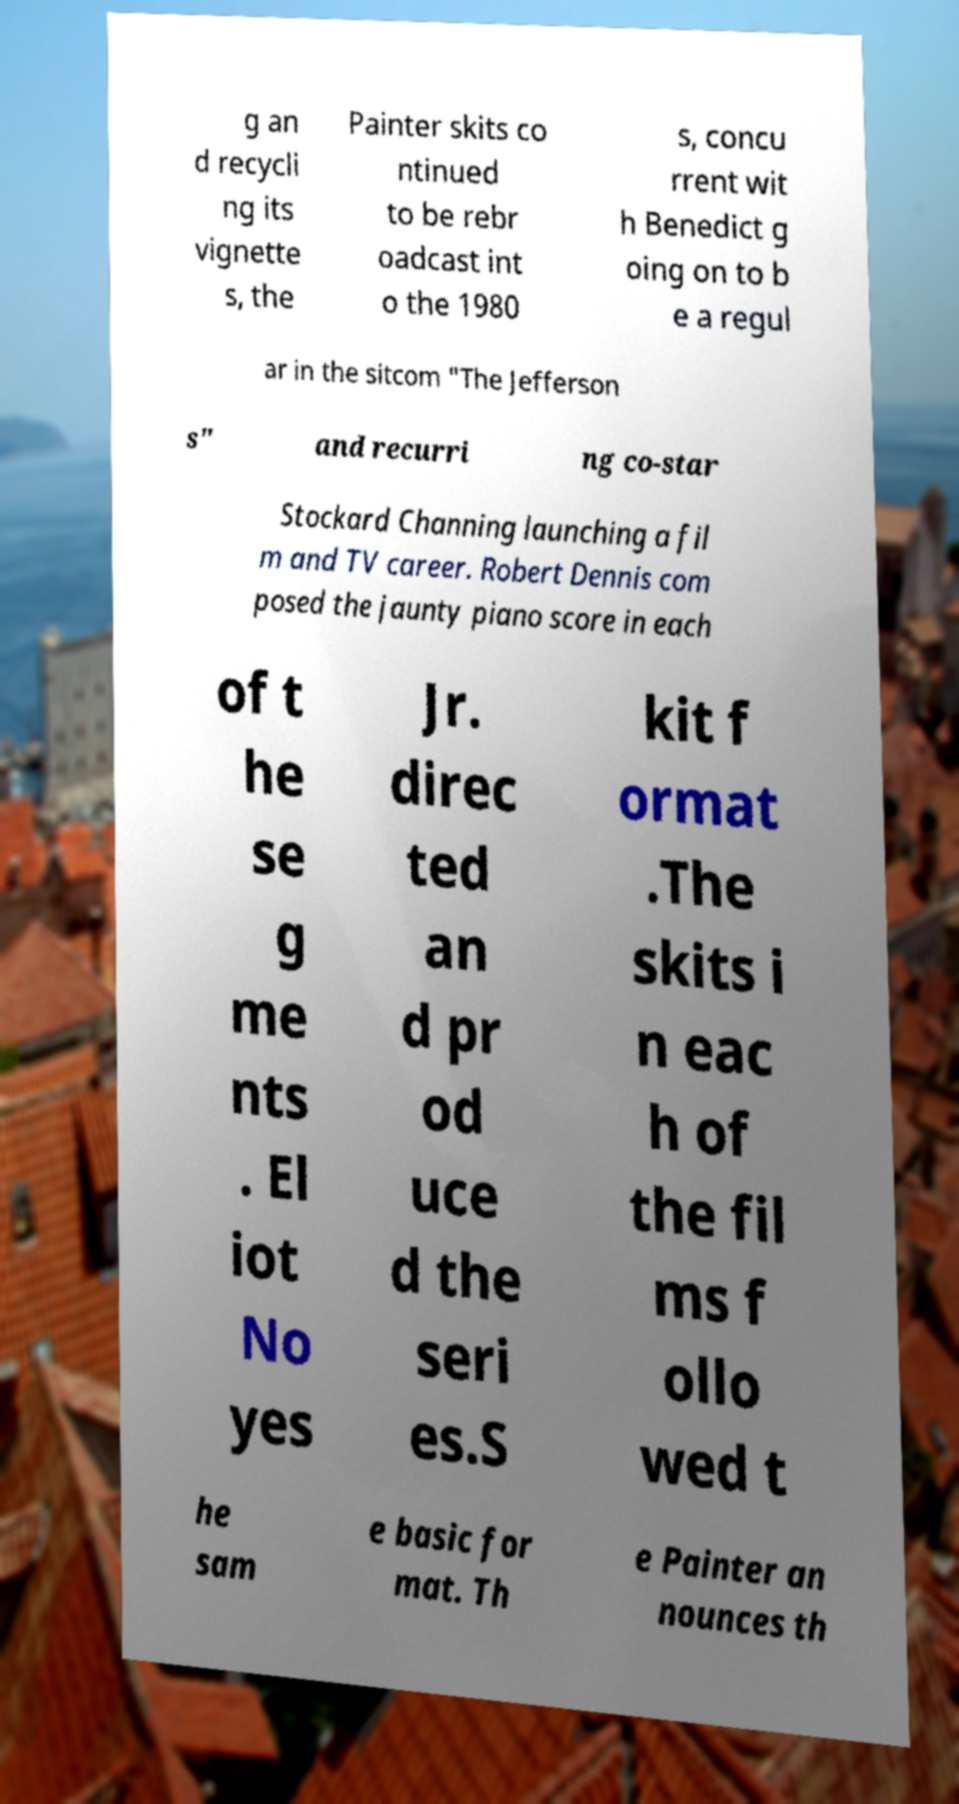For documentation purposes, I need the text within this image transcribed. Could you provide that? g an d recycli ng its vignette s, the Painter skits co ntinued to be rebr oadcast int o the 1980 s, concu rrent wit h Benedict g oing on to b e a regul ar in the sitcom "The Jefferson s" and recurri ng co-star Stockard Channing launching a fil m and TV career. Robert Dennis com posed the jaunty piano score in each of t he se g me nts . El iot No yes Jr. direc ted an d pr od uce d the seri es.S kit f ormat .The skits i n eac h of the fil ms f ollo wed t he sam e basic for mat. Th e Painter an nounces th 